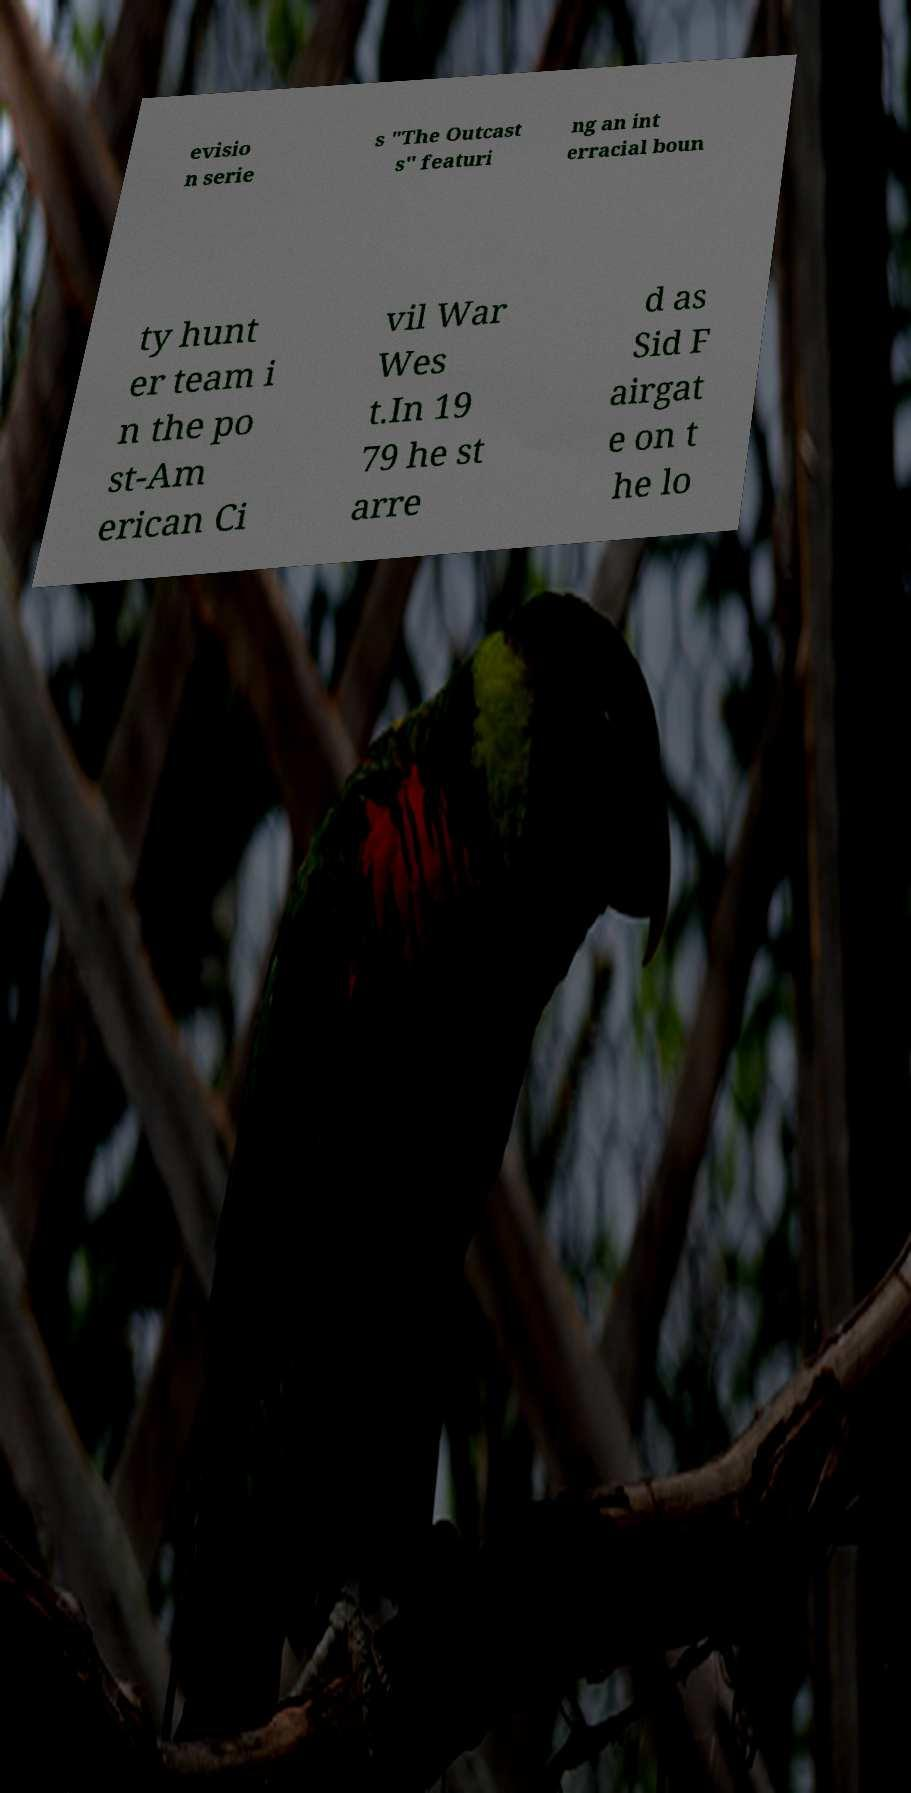I need the written content from this picture converted into text. Can you do that? evisio n serie s "The Outcast s" featuri ng an int erracial boun ty hunt er team i n the po st-Am erican Ci vil War Wes t.In 19 79 he st arre d as Sid F airgat e on t he lo 